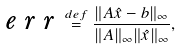Convert formula to latex. <formula><loc_0><loc_0><loc_500><loc_500>\emph { e r r } \stackrel { d e f } { = } \frac { \| A \hat { x } - b \| _ { \infty } } { \| A \| _ { \infty } \| \hat { x } \| _ { \infty } } ,</formula> 